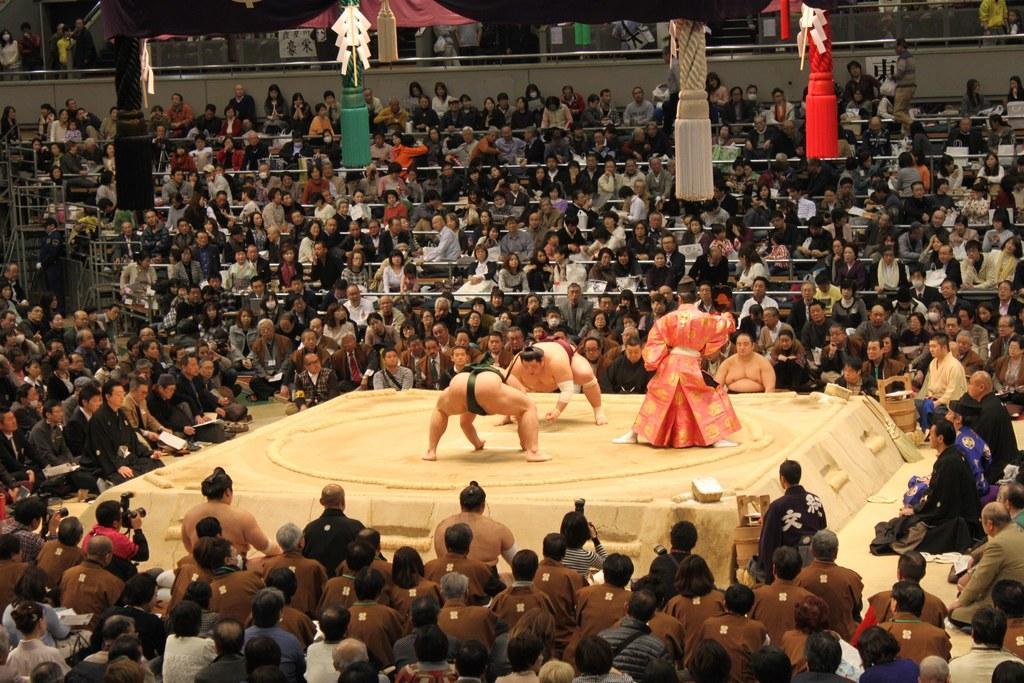In one or two sentences, can you explain what this image depicts? In the image we can see there are some people playing a sumo game. There are people sitting around and some of them are standing, they are wearing clothes. Here we can see the decorative poles and the wall. 